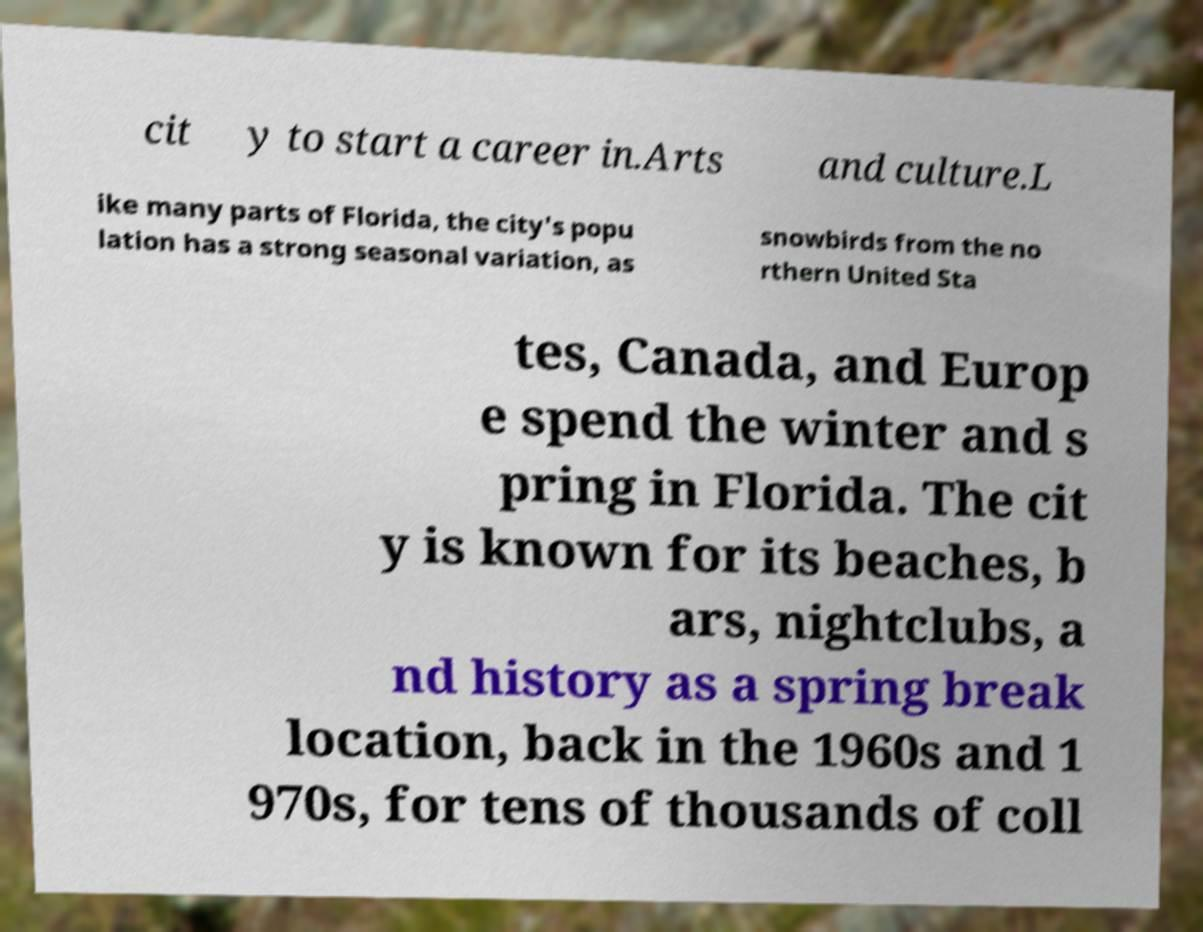For documentation purposes, I need the text within this image transcribed. Could you provide that? cit y to start a career in.Arts and culture.L ike many parts of Florida, the city's popu lation has a strong seasonal variation, as snowbirds from the no rthern United Sta tes, Canada, and Europ e spend the winter and s pring in Florida. The cit y is known for its beaches, b ars, nightclubs, a nd history as a spring break location, back in the 1960s and 1 970s, for tens of thousands of coll 